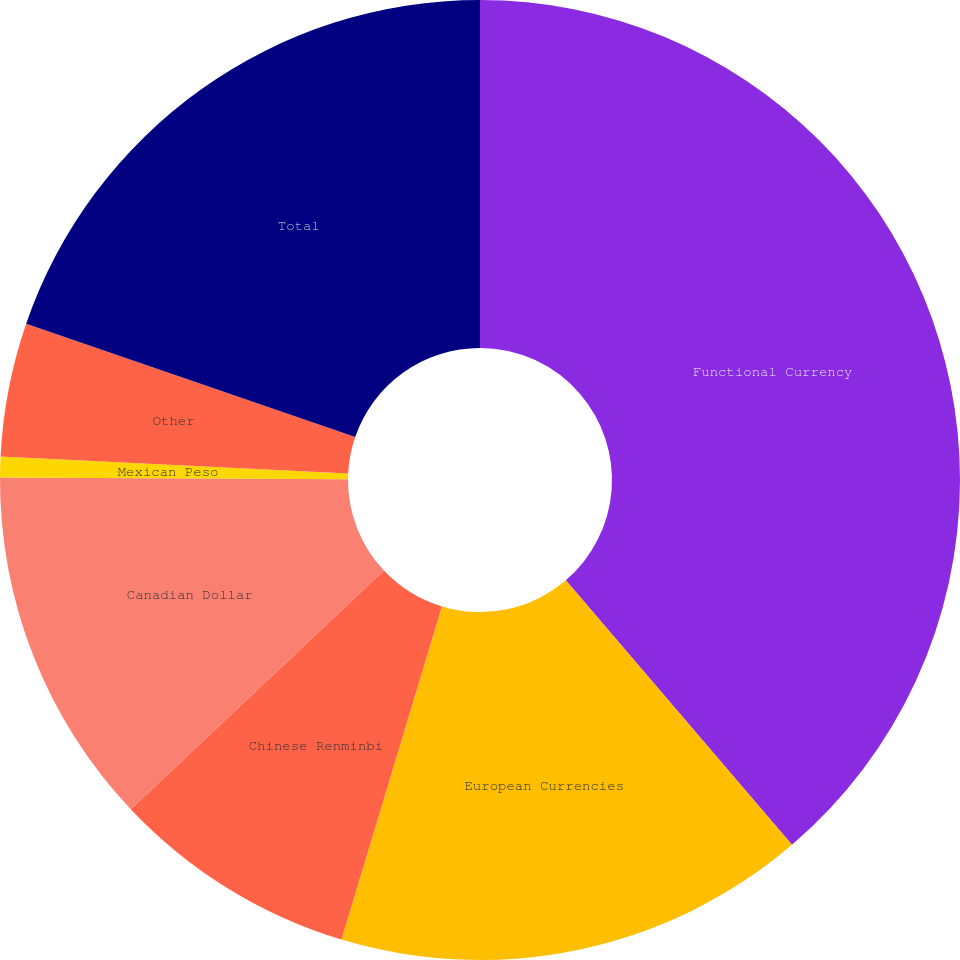Convert chart. <chart><loc_0><loc_0><loc_500><loc_500><pie_chart><fcel>Functional Currency<fcel>European Currencies<fcel>Chinese Renminbi<fcel>Canadian Dollar<fcel>Mexican Peso<fcel>Other<fcel>Total<nl><fcel>38.74%<fcel>15.92%<fcel>8.31%<fcel>12.11%<fcel>0.7%<fcel>4.5%<fcel>19.72%<nl></chart> 